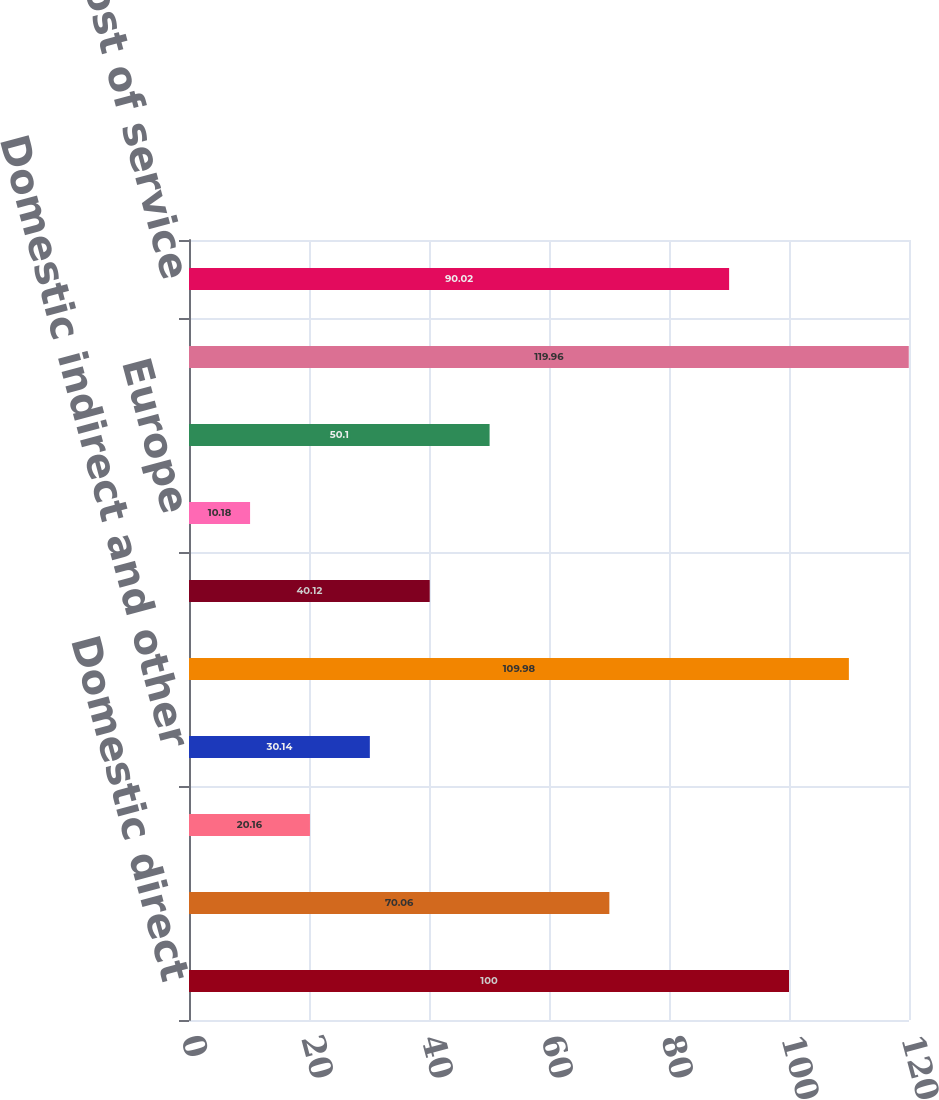Convert chart to OTSL. <chart><loc_0><loc_0><loc_500><loc_500><bar_chart><fcel>Domestic direct<fcel>Canada<fcel>Central and Eastern Europe<fcel>Domestic indirect and other<fcel>Merchant services<fcel>Domestic<fcel>Europe<fcel>Money transfer<fcel>Total revenues<fcel>Cost of service<nl><fcel>100<fcel>70.06<fcel>20.16<fcel>30.14<fcel>109.98<fcel>40.12<fcel>10.18<fcel>50.1<fcel>119.96<fcel>90.02<nl></chart> 